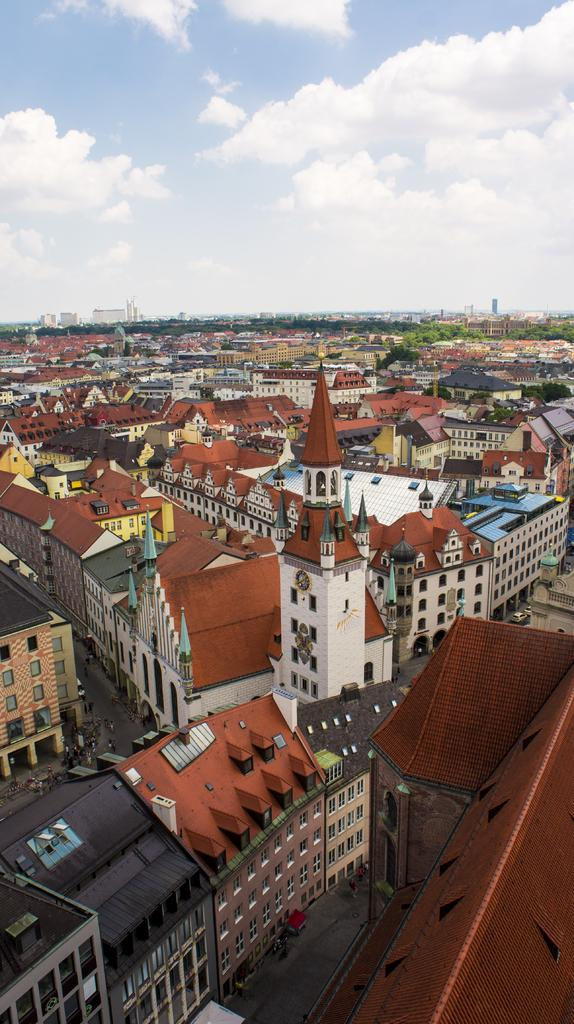What type of structures are present in the image? There is a group of buildings with windows and a tower with a clock in the image. What can be seen on the tower? There is a clock on the tower. What else is visible in the image besides the buildings and tower? There are roads and trees visible in the image. What is visible in the background of the image? The sky and trees are visible in the background of the image. How would you describe the sky in the image? The sky appears cloudy in the image. What is the rate of the falling leaves in the image? There are no leaves visible in the image, so it is not possible to determine the rate of any falling leaves. 